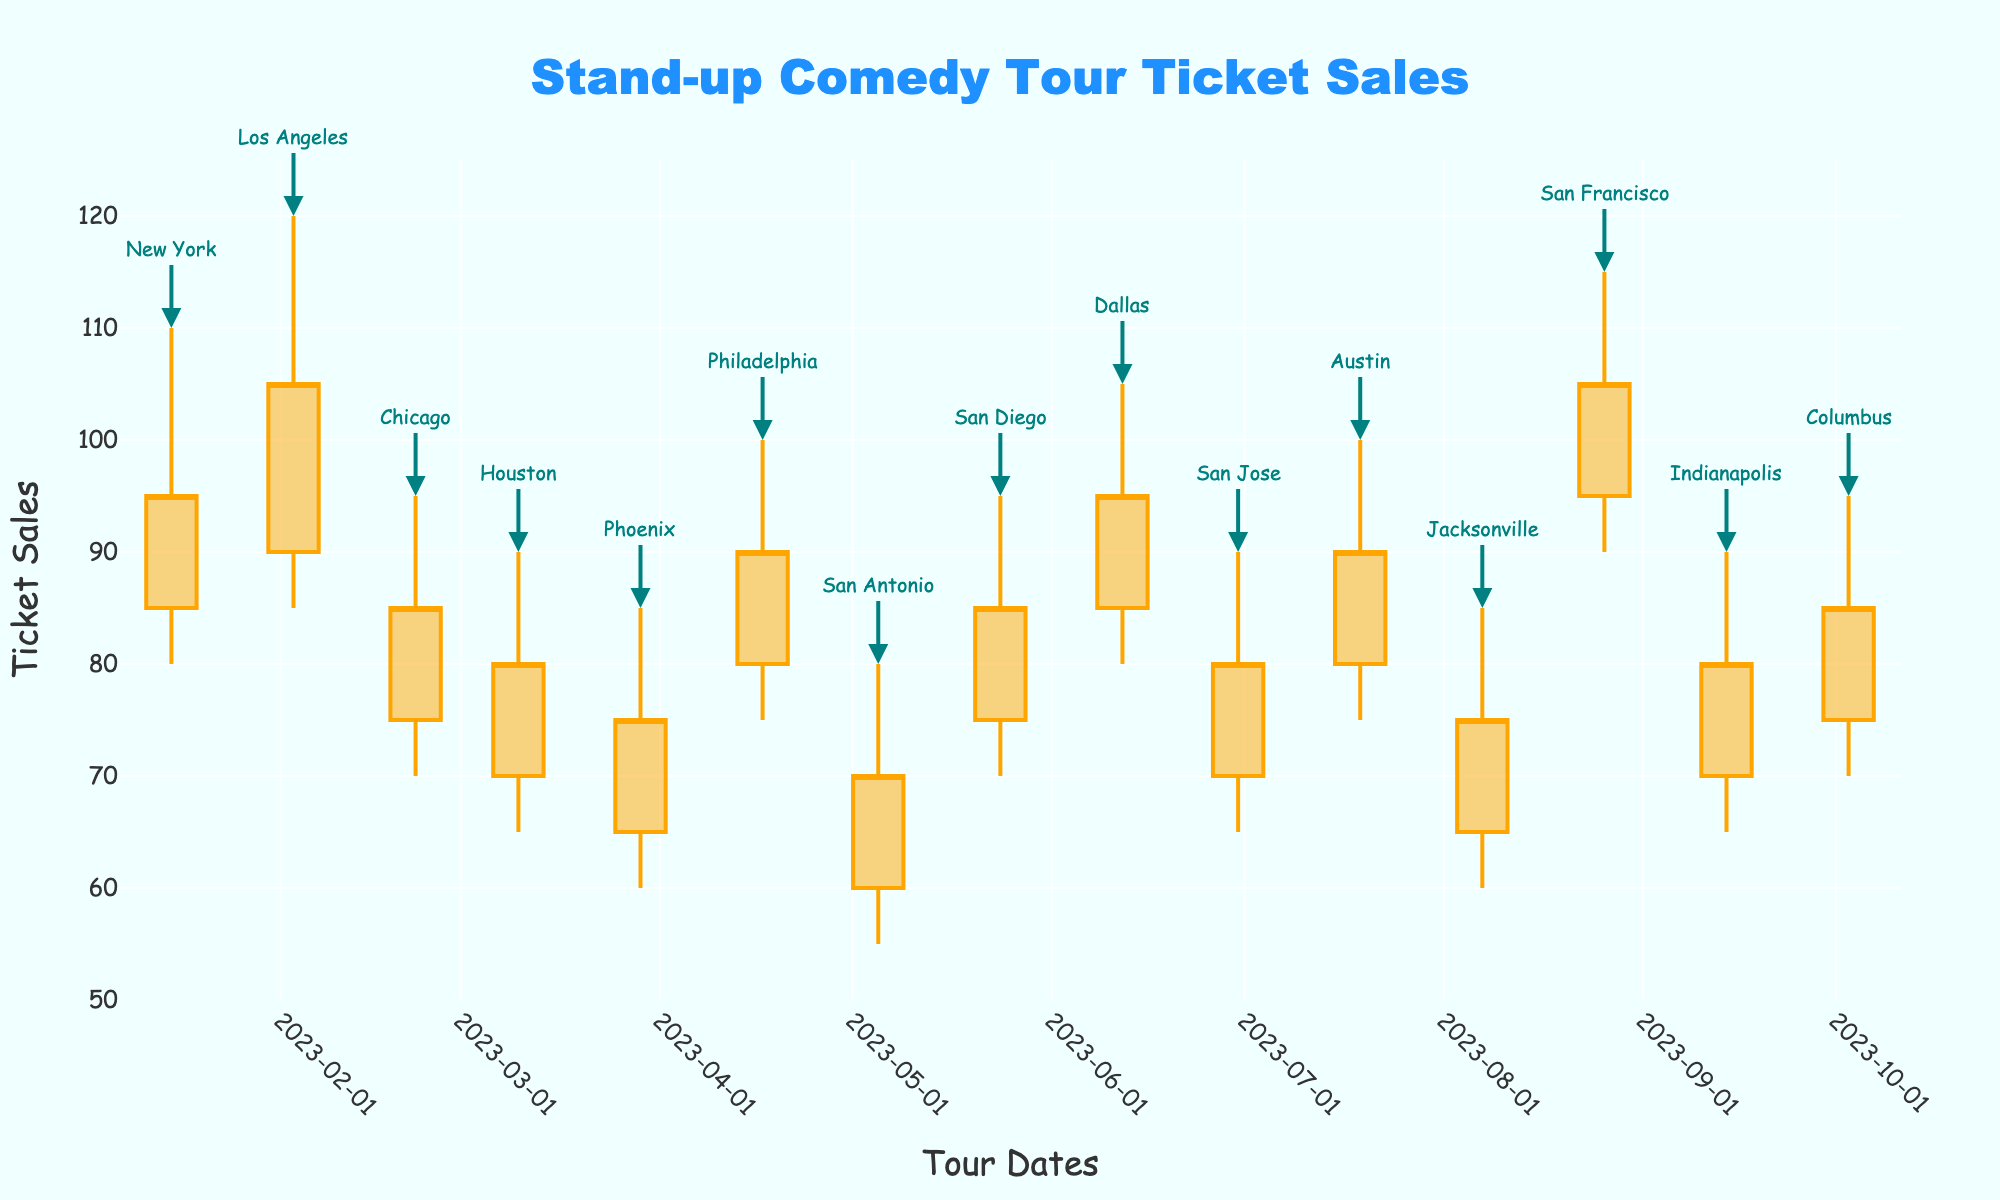How is the title of the chart described? Examining the top of the figure, the title is centrally positioned and states "Stand-up Comedy Tour Ticket Sales" in a prominent, large font.
Answer: Stand-up Comedy Tour Ticket Sales What is the color used for indicating increasing ticket sales? The lines representing increasing ticket sales are colored orange, making them easily distinguishable from the decreasing ticket sales.
Answer: Orange How many city labels are annotated in the chart? Each entry on the chart has an associated city label, with one annotation per date, leading to a total of 15 city labels since there are 15 entries in the dataset.
Answer: 15 Which city had the highest ticket sales peak, and what was the value? Observing the chart, the highest peak is found in San Francisco on August 26, with a value reaching up to 115.
Answer: San Francisco, 115 What is the average closing ticket sales value across all cities? The closing values for all cities are: 95, 105, 85, 80, 75, 90, 70, 85, 95, 80, 90, 75, 105, 80, 85. Summing these values gives 1200, then dividing by the number of cities (15) results in an average of 80.
Answer: 80 Which city experienced the greatest range in ticket sales and what was the value? The range is determined by subtracting the low from the high values for each city. Los Angeles had the greatest range: 120 - 85 = 35.
Answer: Los Angeles, 35 Which cities had a close value higher than the open value and how many were there? By comparing the close and open values, the cities with higher closing values are New York, Los Angeles, Philadelphia, Dallas, Austin, and San Francisco, totaling 6 cities.
Answer: 6 Was there an increasing or decreasing trend in ticket sales in Houston? Analyzing the Houston segment, the open value (70) is less than the close value (80), indicating an increasing trend.
Answer: Increasing Identify the cities where the ticket sales did not vary much (consider a range of <=10). Cities with a range of ticket sales 10 or less are Houston (range 25), Phoenix (range 25), San Antonio (range 25), San Diego (range 25), Dallas (range 25), Austin (range 25), Columbus (range 25). These cities have a range of >10.
Answer: None 